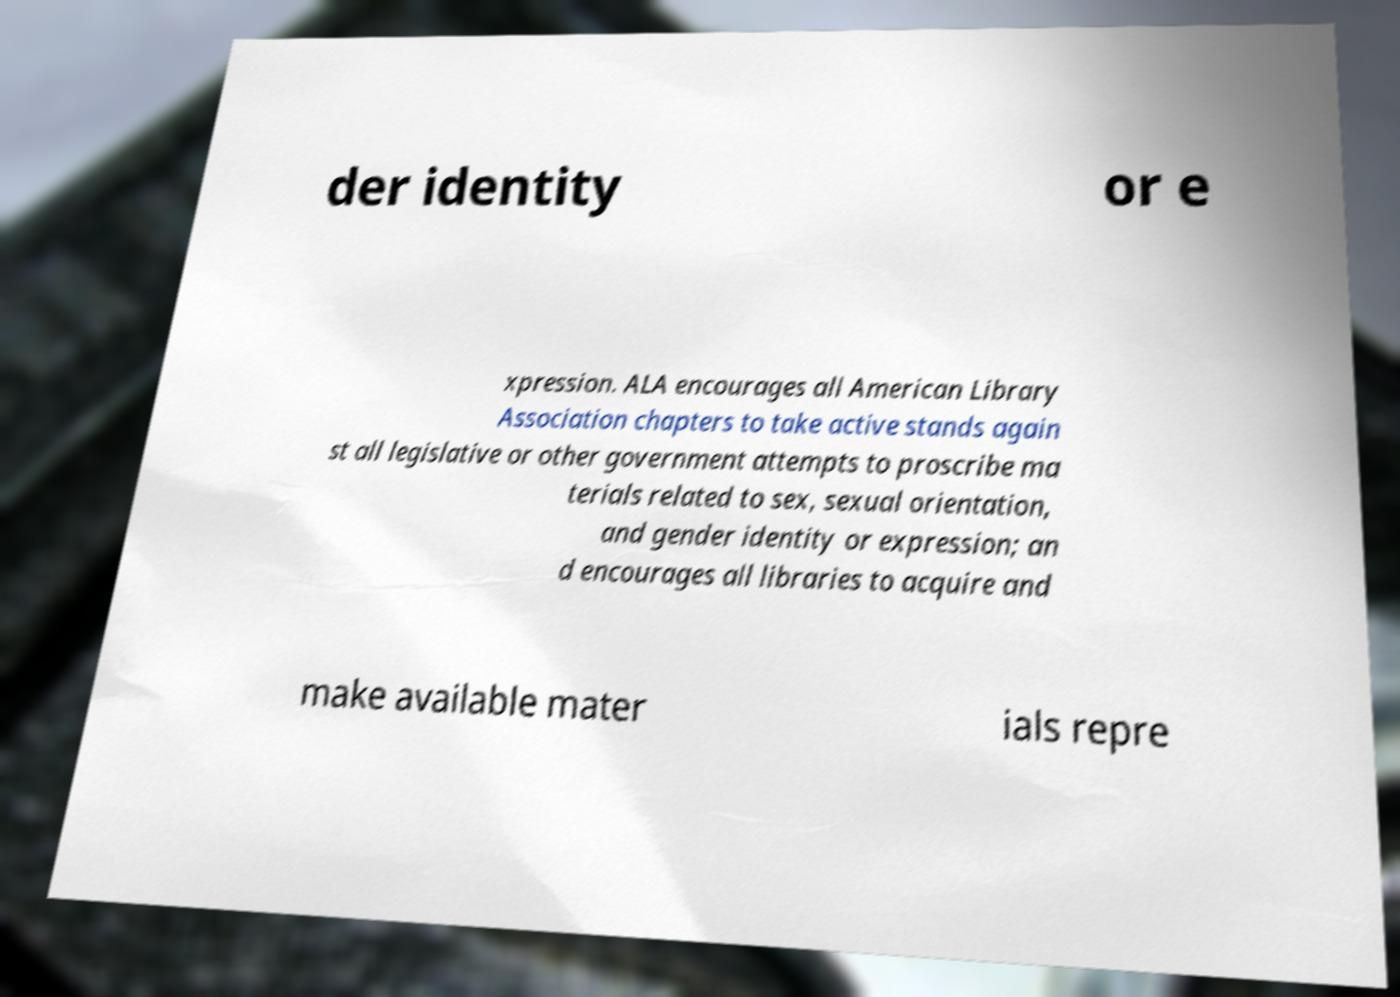Could you extract and type out the text from this image? der identity or e xpression. ALA encourages all American Library Association chapters to take active stands again st all legislative or other government attempts to proscribe ma terials related to sex, sexual orientation, and gender identity or expression; an d encourages all libraries to acquire and make available mater ials repre 